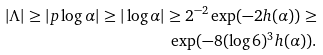<formula> <loc_0><loc_0><loc_500><loc_500>| \Lambda | \geq | p \log \alpha | \geq | \log \alpha | \geq 2 ^ { - 2 } \exp ( - 2 h ( \alpha ) ) \geq \\ \exp ( - 8 ( \log 6 ) ^ { 3 } h ( \alpha ) ) .</formula> 